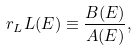<formula> <loc_0><loc_0><loc_500><loc_500>r _ { L } L ( E ) \equiv \frac { B ( E ) } { A ( E ) } ,</formula> 